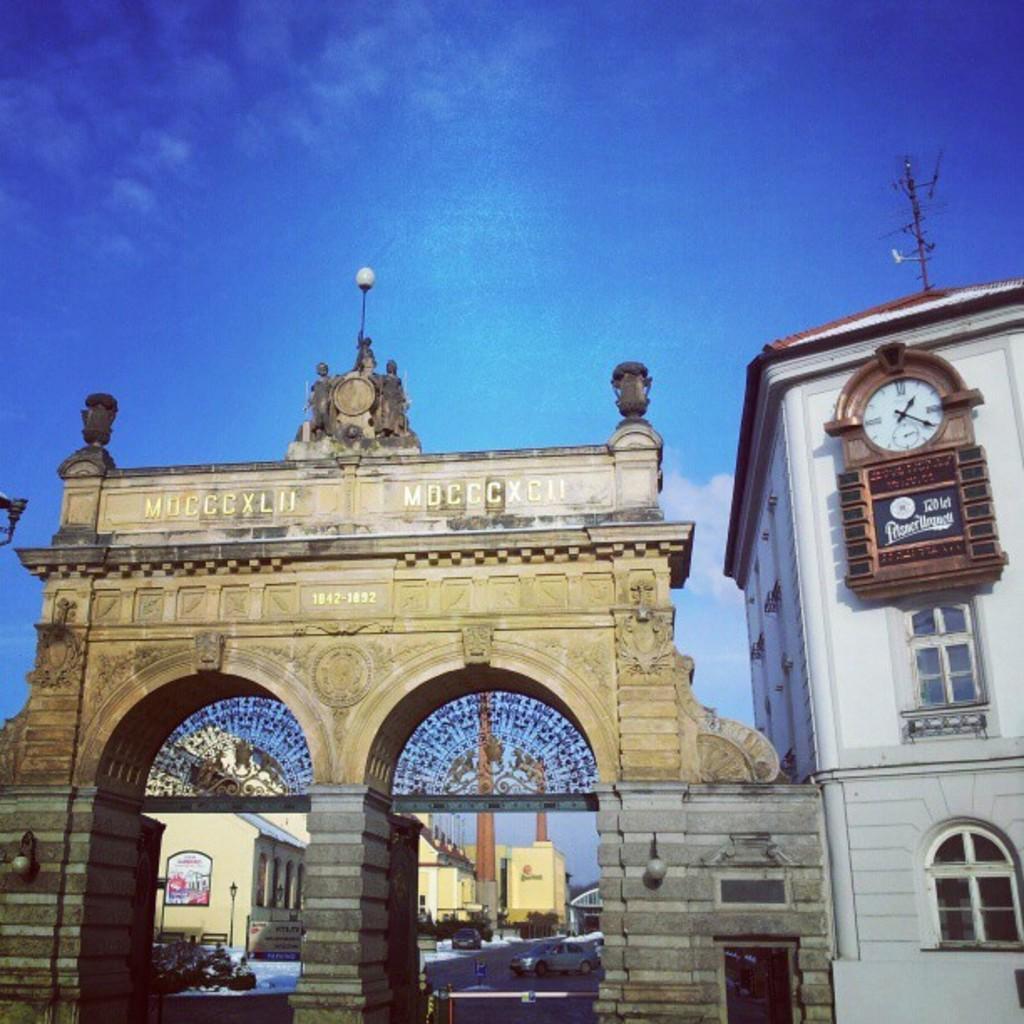Can you describe this image briefly? There is an entrance with pillars and arches. And something is written on that. Near to that there is a building with windows and clock on it. On that there is an antenna. In the background there are buildings, pillars and road with vehicles. In the background there is sky. 